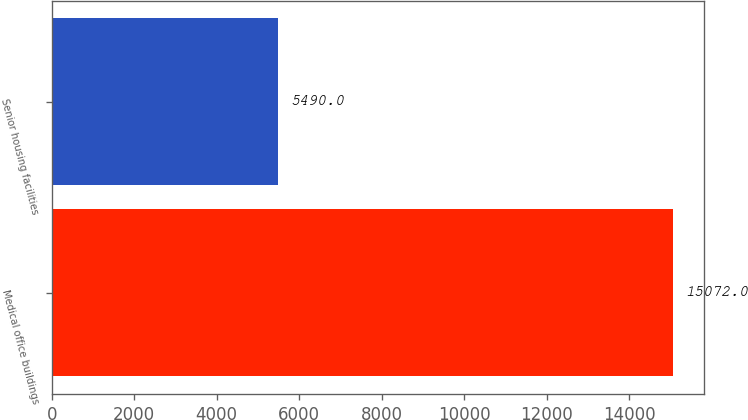Convert chart to OTSL. <chart><loc_0><loc_0><loc_500><loc_500><bar_chart><fcel>Medical office buildings<fcel>Senior housing facilities<nl><fcel>15072<fcel>5490<nl></chart> 